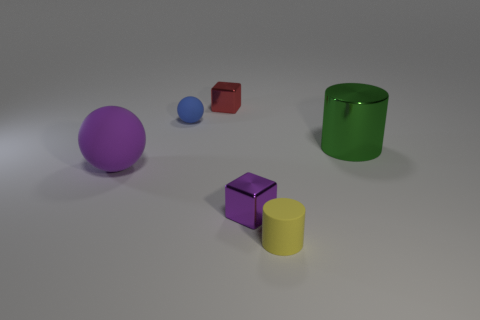There is a ball that is the same material as the small blue thing; what is its color?
Make the answer very short. Purple. What shape is the large green metal object?
Keep it short and to the point. Cylinder. What number of small cubes are the same color as the big matte object?
Offer a terse response. 1. There is a red metallic thing that is the same size as the blue sphere; what is its shape?
Ensure brevity in your answer.  Cube. Is there a object that has the same size as the purple metal block?
Keep it short and to the point. Yes. What is the material of the blue sphere that is the same size as the yellow cylinder?
Give a very brief answer. Rubber. What size is the matte thing that is right of the tiny object that is behind the tiny blue matte ball?
Offer a terse response. Small. There is a cube behind the purple cube; is it the same size as the big purple ball?
Offer a very short reply. No. Is the number of tiny things that are left of the yellow object greater than the number of big purple rubber spheres that are to the right of the tiny blue rubber ball?
Your answer should be compact. Yes. There is a tiny thing that is both behind the large purple rubber sphere and on the right side of the blue object; what shape is it?
Give a very brief answer. Cube. 